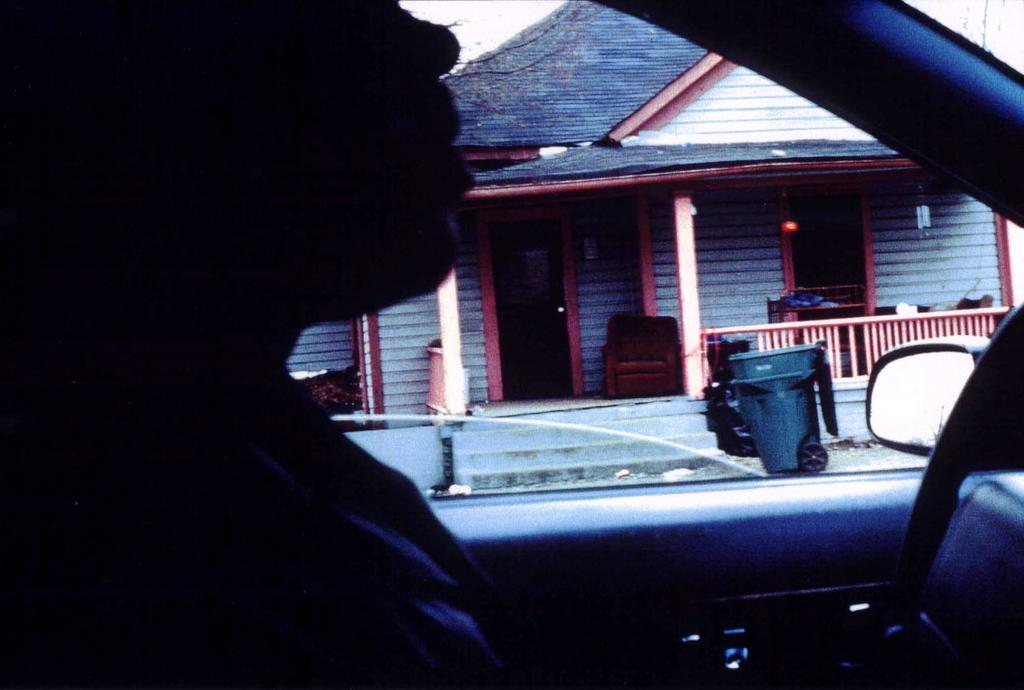What is the main subject of the image? There is a person inside a vehicle in the image. What is one object visible in the vehicle? There is a mirror in the image. What is another object visible outside the vehicle? There is a bin in the image. What type of structure can be seen in the background? There is a house in the image. What is the condition of the sky in the image? The sky is visible in the image. What is the price of the alley seen in the image? There is no alley present in the image, and therefore no price can be determined. What type of care is the person providing to the vehicle in the image? The image does not show any indication of the person providing care to the vehicle, so it cannot be determined from the picture. 